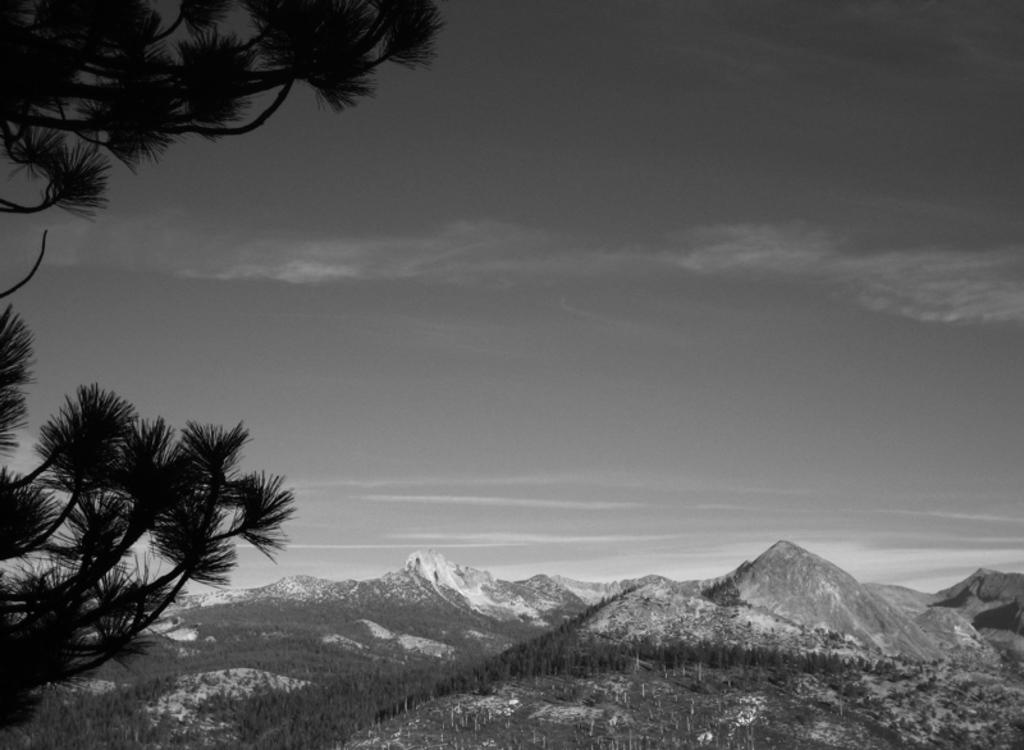What can be seen in the sky in the image? The sky with clouds is visible in the image. What type of landscape feature is present in the image? There are hills in the image. What type of vegetation is present in the image? Trees are present in the image. What is visible at the bottom of the image? The ground is visible in the image. Can you see the mom holding the cable in the image? There is no mom or cable present in the image. What type of vein is visible in the image? There are no veins visible in the image; it features natural elements such as the sky, clouds, hills, trees, and ground. 